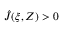Convert formula to latex. <formula><loc_0><loc_0><loc_500><loc_500>\hat { J } ( \xi , Z ) > 0</formula> 